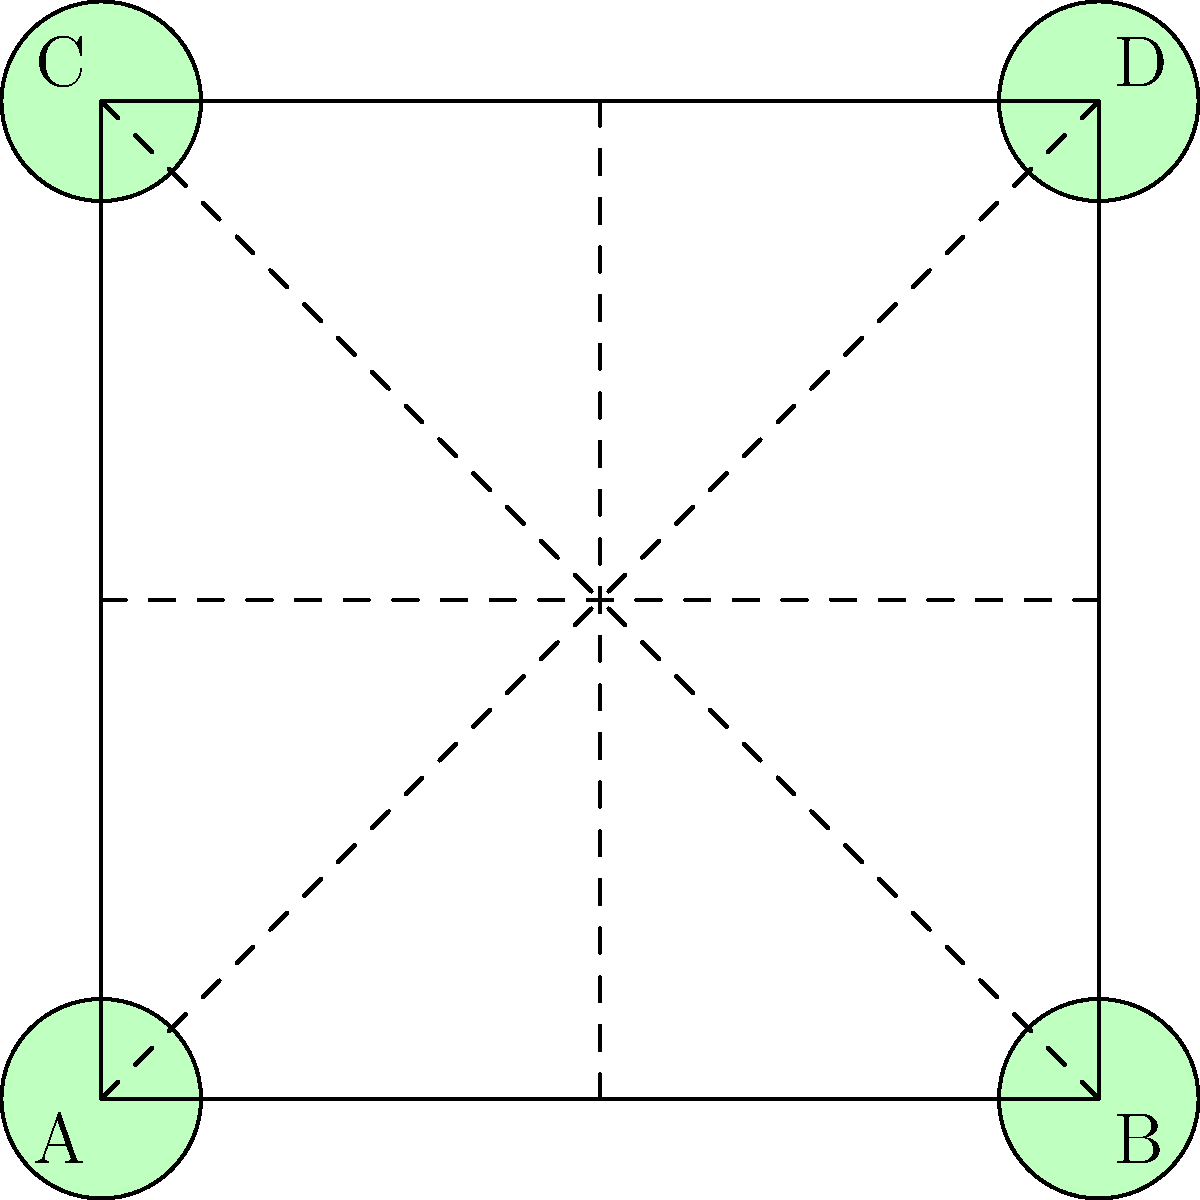In a gymnastics formation, four gymnasts (A, B, C, and D) are positioned at the corners of a square. This configuration represents the dihedral group $D_4$. How many subgroups of order 2 does this group have, and what gymnast movements do they correspond to? Let's approach this step-by-step:

1) The dihedral group $D_4$ has 8 elements in total: 4 rotations and 4 reflections.

2) Subgroups of order 2 are cyclic groups with two elements: the identity and one other element.

3) To find these subgroups, we need to identify elements of order 2 in $D_4$:

   a) The 180° rotation (diagonal flip): ABCD → CDAB
   b) Vertical reflection: ABCD → BADC
   c) Horizontal reflection: ABCD → CDAB
   d) Diagonal reflection (top-left to bottom-right): ABCD → ACBD
   e) Diagonal reflection (top-right to bottom-left): ABCD → CADB

4) Each of these elements, combined with the identity (no movement), forms a subgroup of order 2.

5) Therefore, there are 5 subgroups of order 2 in $D_4$.

6) In terms of gymnast movements:
   - 180° rotation: Gymnasts swap diagonally
   - Vertical reflection: A-B and C-D swap places
   - Horizontal reflection: A-C and B-D swap places
   - Diagonal reflections: Gymnasts on one diagonal stay put, others swap

These movements demonstrate the resilience and flexibility required in gymnastics, as the gymnasts must be prepared to quickly change positions while maintaining the overall square formation.
Answer: 5 subgroups, corresponding to 1 rotation and 4 reflections 